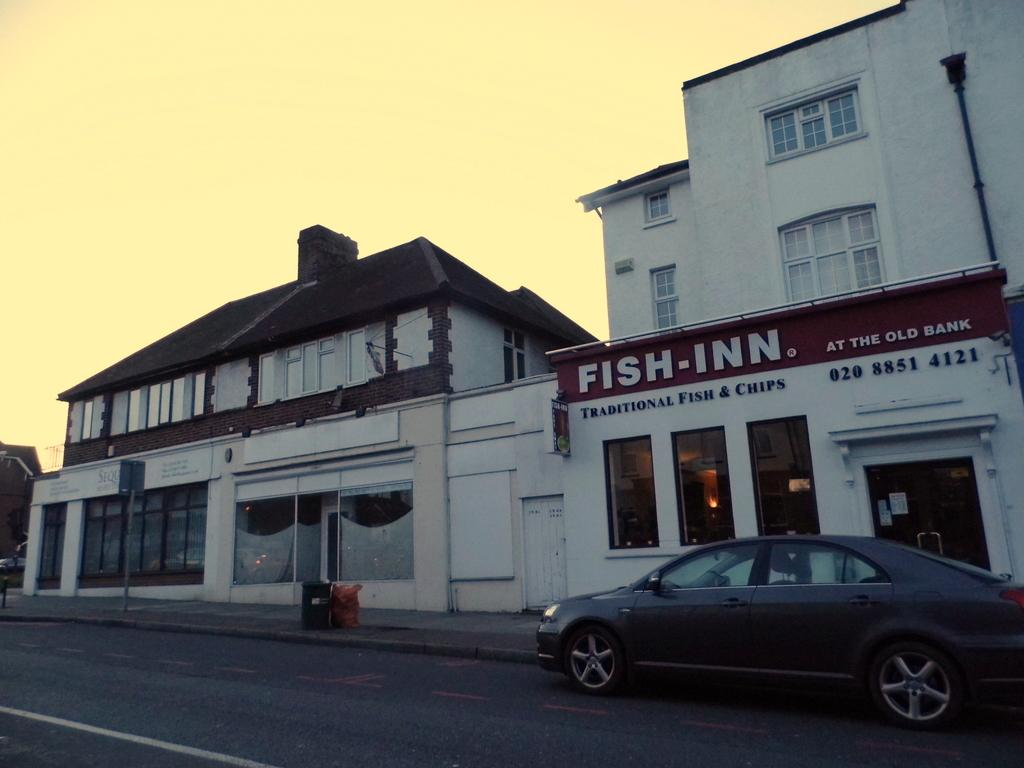What type of structures can be seen in the image? There are buildings in the image. What mode of transportation is visible on the road? There is a car standing on the road in the image. What type of coat is the car wearing in the image? Cars do not wear coats; they are vehicles. The question is not relevant to the image. 